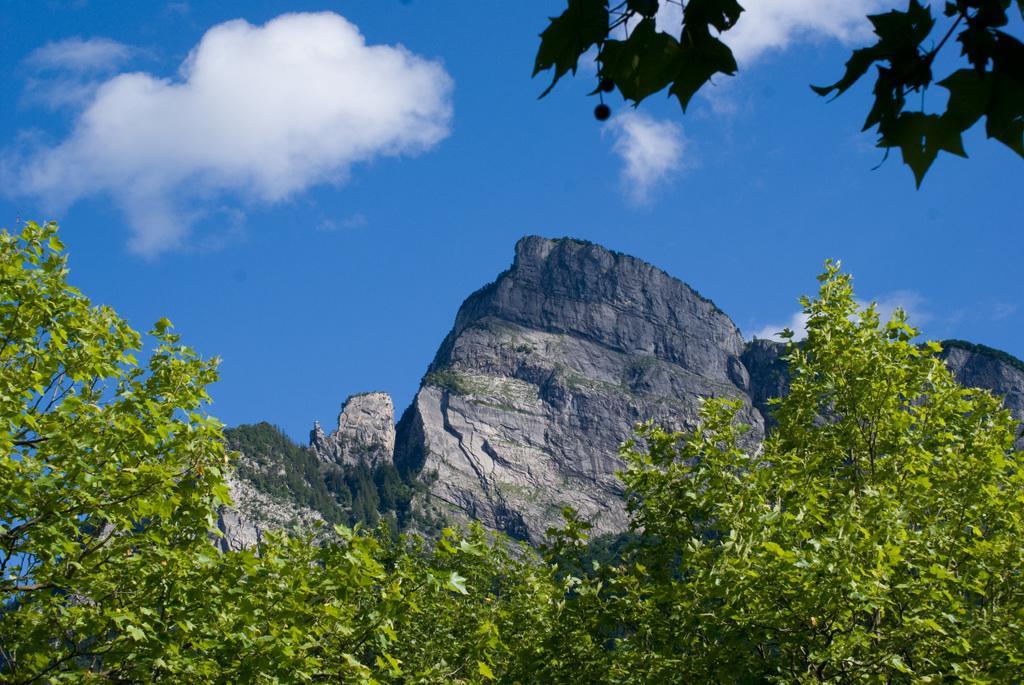In one or two sentences, can you explain what this image depicts? In this image I can see green colour leaves, clouds and the sky. 